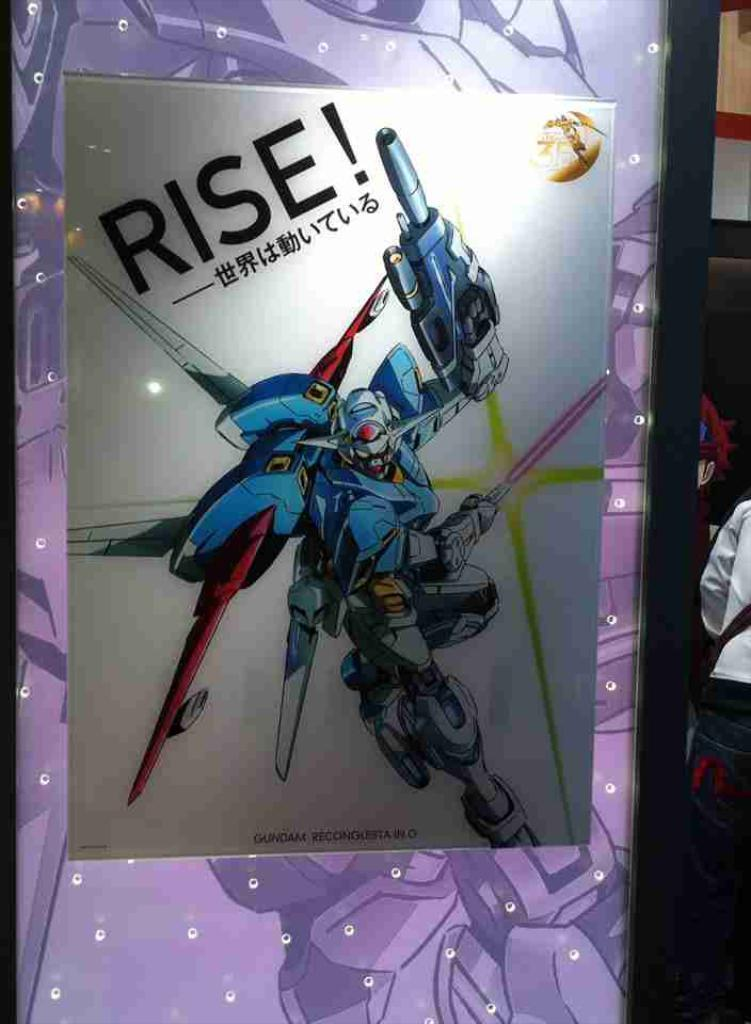What is the main object in the center of the image? There is a glass board in the center of the image. What is on the glass board? There is a poster on the glass board. What can be found on the poster? The poster contains text and a toy. Where are the persons located in the image? A: The persons are on the right side of the image. What type of beef is being served to the lawyer in the image? There is no beef or lawyer present in the image. 